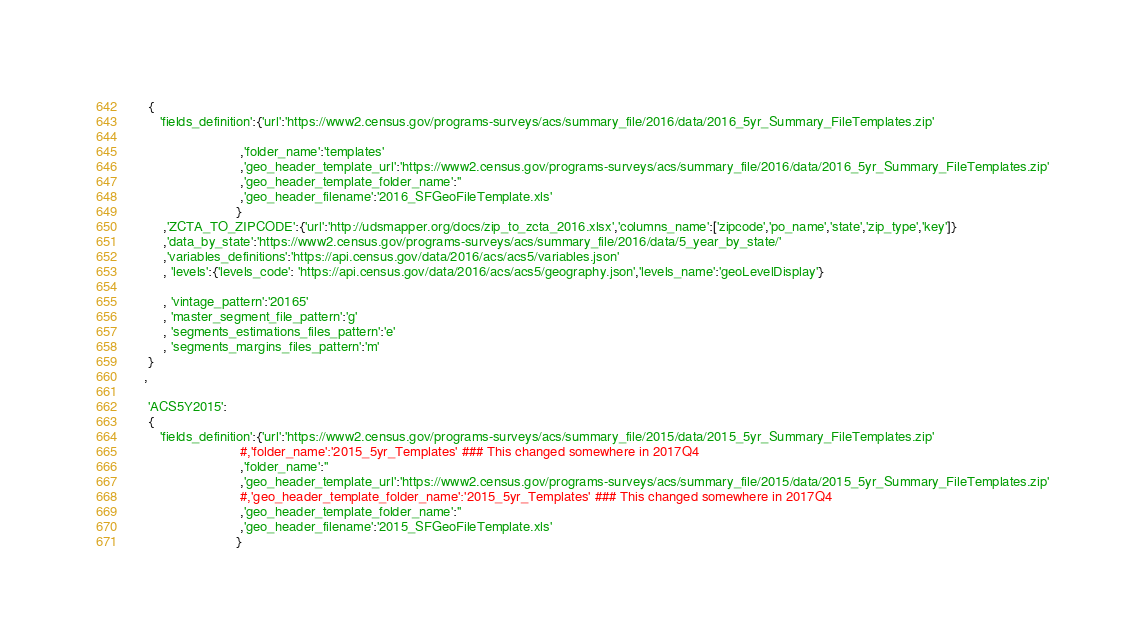<code> <loc_0><loc_0><loc_500><loc_500><_Python_>     {
        'fields_definition':{'url':'https://www2.census.gov/programs-surveys/acs/summary_file/2016/data/2016_5yr_Summary_FileTemplates.zip'

                             ,'folder_name':'templates'
                             ,'geo_header_template_url':'https://www2.census.gov/programs-surveys/acs/summary_file/2016/data/2016_5yr_Summary_FileTemplates.zip'
                             ,'geo_header_template_folder_name':''
                             ,'geo_header_filename':'2016_SFGeoFileTemplate.xls'
                            }
         ,'ZCTA_TO_ZIPCODE':{'url':'http://udsmapper.org/docs/zip_to_zcta_2016.xlsx','columns_name':['zipcode','po_name','state','zip_type','key']}
         ,'data_by_state':'https://www2.census.gov/programs-surveys/acs/summary_file/2016/data/5_year_by_state/'
         ,'variables_definitions':'https://api.census.gov/data/2016/acs/acs5/variables.json'
         , 'levels':{'levels_code': 'https://api.census.gov/data/2016/acs/acs5/geography.json','levels_name':'geoLevelDisplay'}
         
         , 'vintage_pattern':'20165'
         , 'master_segment_file_pattern':'g'
         , 'segments_estimations_files_pattern':'e'
         , 'segments_margins_files_pattern':'m'
     }
    ,
    
     'ACS5Y2015':
     {
        'fields_definition':{'url':'https://www2.census.gov/programs-surveys/acs/summary_file/2015/data/2015_5yr_Summary_FileTemplates.zip'
                             #,'folder_name':'2015_5yr_Templates' ### This changed somewhere in 2017Q4
                             ,'folder_name':''
                             ,'geo_header_template_url':'https://www2.census.gov/programs-surveys/acs/summary_file/2015/data/2015_5yr_Summary_FileTemplates.zip'
                             #,'geo_header_template_folder_name':'2015_5yr_Templates' ### This changed somewhere in 2017Q4
                             ,'geo_header_template_folder_name':''
                             ,'geo_header_filename':'2015_SFGeoFileTemplate.xls'
                            }</code> 